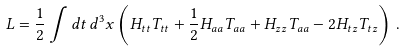<formula> <loc_0><loc_0><loc_500><loc_500>L = \frac { 1 } { 2 } \int d t \, d ^ { 3 } x \left ( H _ { t t } T _ { t t } + \frac { 1 } { 2 } H _ { a a } T _ { a a } + H _ { z z } T _ { a a } - 2 H _ { t z } T _ { t z } \right ) \, .</formula> 